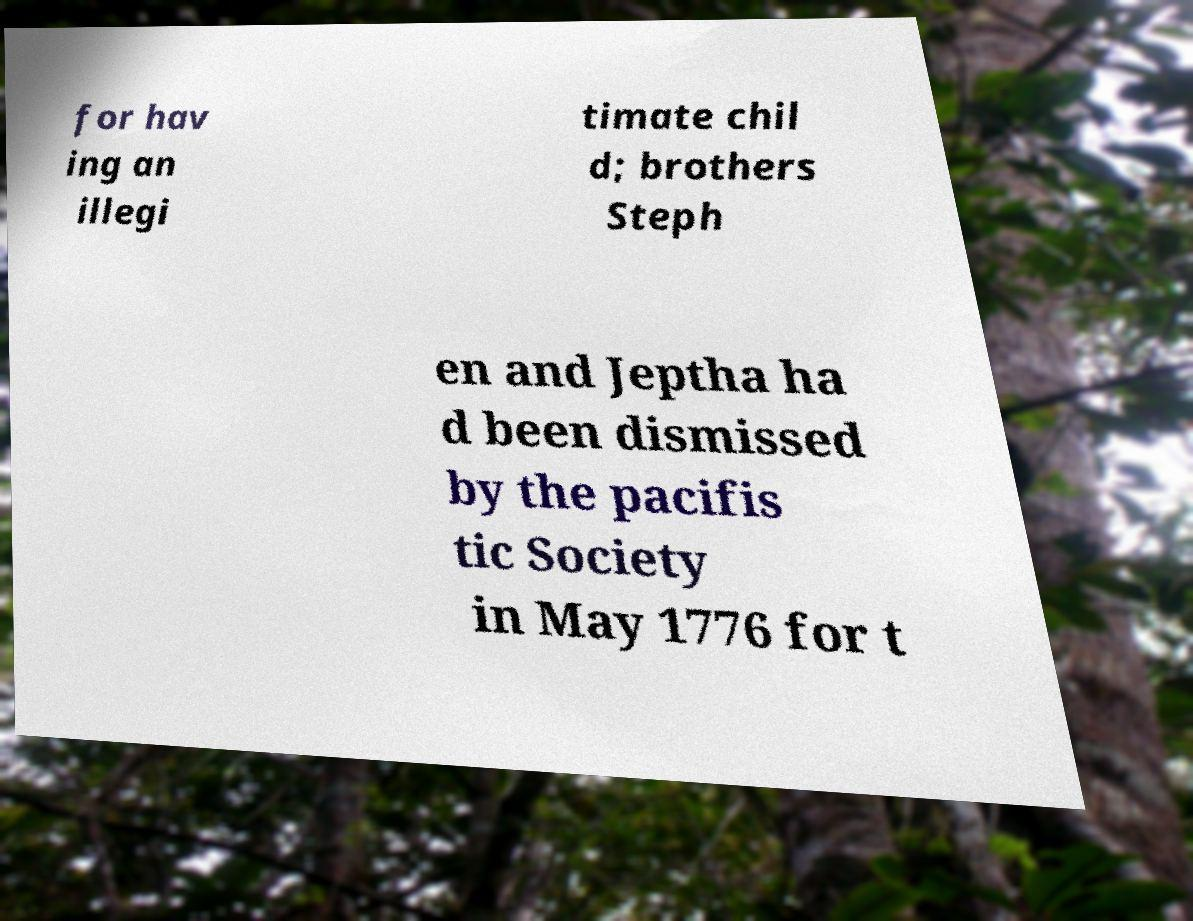I need the written content from this picture converted into text. Can you do that? for hav ing an illegi timate chil d; brothers Steph en and Jeptha ha d been dismissed by the pacifis tic Society in May 1776 for t 